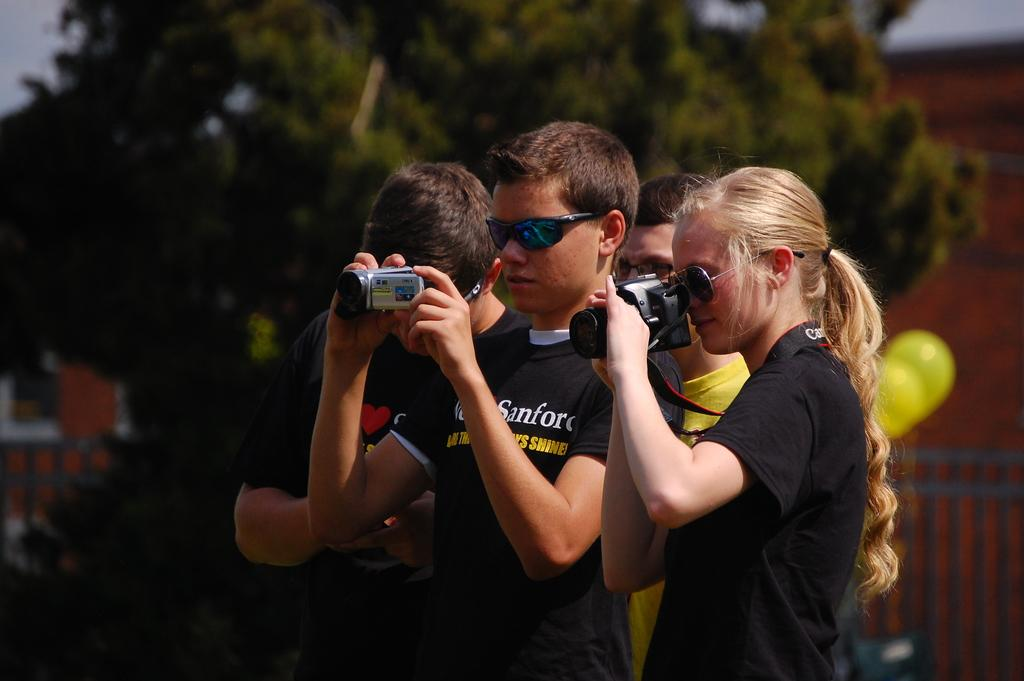What is happening in the image? There is a group of people in the image. What are the people holding in their hands? The people are holding a camera in their hands. What is the temperature in the image? The temperature cannot be determined from the image, as it does not contain any information about the weather or environment. 